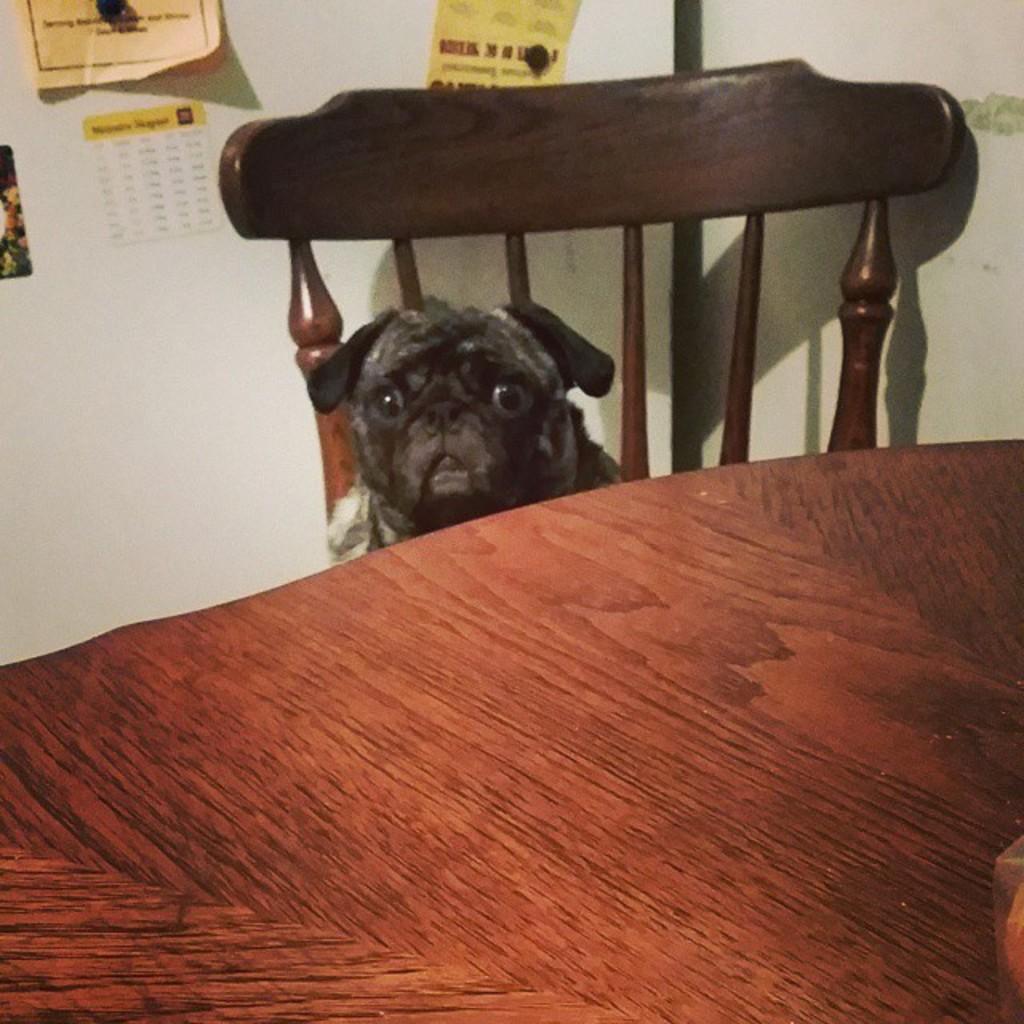Can you describe this image briefly? This is a table and there is a chair. Here we can see a dog. There is a wall and these are the posters. 